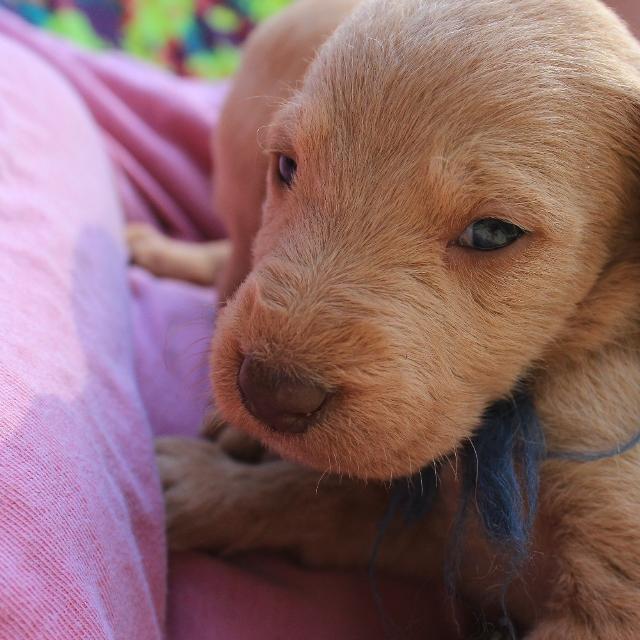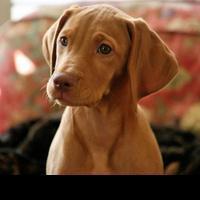The first image is the image on the left, the second image is the image on the right. Evaluate the accuracy of this statement regarding the images: "A dog is laying in grass.". Is it true? Answer yes or no. No. The first image is the image on the left, the second image is the image on the right. For the images shown, is this caption "The left and right image contains the same number of puppies." true? Answer yes or no. Yes. 